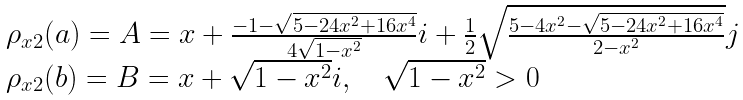Convert formula to latex. <formula><loc_0><loc_0><loc_500><loc_500>\begin{array} { l } \rho _ { x 2 } ( a ) = A = x + \frac { - 1 - \sqrt { 5 - 2 4 x ^ { 2 } + 1 6 x ^ { 4 } } } { 4 \sqrt { 1 - x ^ { 2 } } } i + \frac { 1 } { 2 } \sqrt { \frac { 5 - 4 x ^ { 2 } - \sqrt { 5 - 2 4 x ^ { 2 } + 1 6 x ^ { 4 } } } { 2 - x ^ { 2 } } } j \\ \rho _ { x 2 } ( b ) = B = x + \sqrt { 1 - x ^ { 2 } } i , \quad \sqrt { 1 - x ^ { 2 } } > 0 \end{array}</formula> 